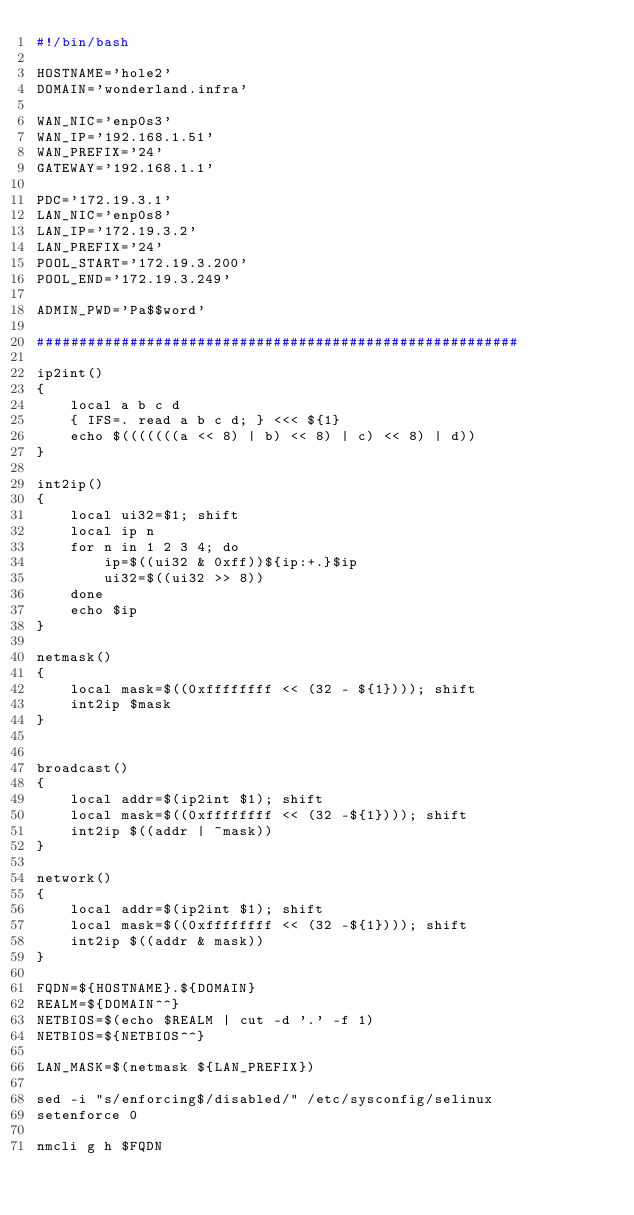Convert code to text. <code><loc_0><loc_0><loc_500><loc_500><_Bash_>#!/bin/bash

HOSTNAME='hole2'
DOMAIN='wonderland.infra'

WAN_NIC='enp0s3'
WAN_IP='192.168.1.51'
WAN_PREFIX='24'
GATEWAY='192.168.1.1'

PDC='172.19.3.1'
LAN_NIC='enp0s8'
LAN_IP='172.19.3.2'
LAN_PREFIX='24'
POOL_START='172.19.3.200'
POOL_END='172.19.3.249'

ADMIN_PWD='Pa$$word'

#########################################################

ip2int()
{
    local a b c d
    { IFS=. read a b c d; } <<< ${1}
    echo $(((((((a << 8) | b) << 8) | c) << 8) | d))
}

int2ip()
{
    local ui32=$1; shift
    local ip n
    for n in 1 2 3 4; do
        ip=$((ui32 & 0xff))${ip:+.}$ip
        ui32=$((ui32 >> 8))
    done
    echo $ip
}

netmask()
{
    local mask=$((0xffffffff << (32 - ${1}))); shift
    int2ip $mask
}


broadcast()
{
    local addr=$(ip2int $1); shift
    local mask=$((0xffffffff << (32 -${1}))); shift
    int2ip $((addr | ~mask))
}

network()
{
    local addr=$(ip2int $1); shift
    local mask=$((0xffffffff << (32 -${1}))); shift
    int2ip $((addr & mask))
}

FQDN=${HOSTNAME}.${DOMAIN}
REALM=${DOMAIN^^}
NETBIOS=$(echo $REALM | cut -d '.' -f 1)
NETBIOS=${NETBIOS^^}

LAN_MASK=$(netmask ${LAN_PREFIX})

sed -i "s/enforcing$/disabled/" /etc/sysconfig/selinux
setenforce 0

nmcli g h $FQDN
</code> 